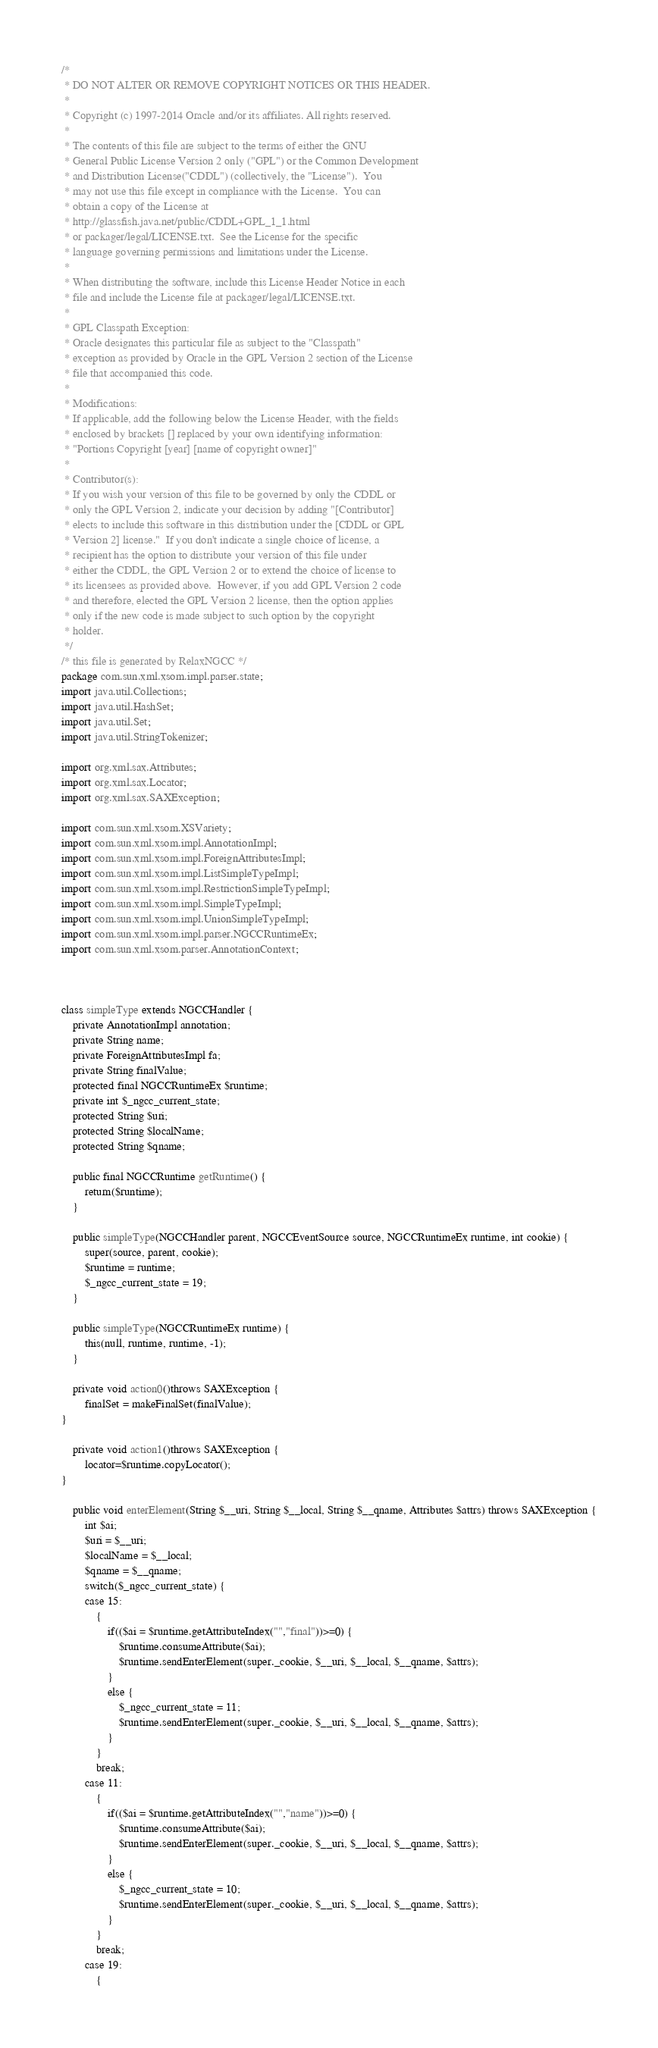Convert code to text. <code><loc_0><loc_0><loc_500><loc_500><_Java_>/*
 * DO NOT ALTER OR REMOVE COPYRIGHT NOTICES OR THIS HEADER.
 *
 * Copyright (c) 1997-2014 Oracle and/or its affiliates. All rights reserved.
 *
 * The contents of this file are subject to the terms of either the GNU
 * General Public License Version 2 only ("GPL") or the Common Development
 * and Distribution License("CDDL") (collectively, the "License").  You
 * may not use this file except in compliance with the License.  You can
 * obtain a copy of the License at
 * http://glassfish.java.net/public/CDDL+GPL_1_1.html
 * or packager/legal/LICENSE.txt.  See the License for the specific
 * language governing permissions and limitations under the License.
 *
 * When distributing the software, include this License Header Notice in each
 * file and include the License file at packager/legal/LICENSE.txt.
 *
 * GPL Classpath Exception:
 * Oracle designates this particular file as subject to the "Classpath"
 * exception as provided by Oracle in the GPL Version 2 section of the License
 * file that accompanied this code.
 *
 * Modifications:
 * If applicable, add the following below the License Header, with the fields
 * enclosed by brackets [] replaced by your own identifying information:
 * "Portions Copyright [year] [name of copyright owner]"
 *
 * Contributor(s):
 * If you wish your version of this file to be governed by only the CDDL or
 * only the GPL Version 2, indicate your decision by adding "[Contributor]
 * elects to include this software in this distribution under the [CDDL or GPL
 * Version 2] license."  If you don't indicate a single choice of license, a
 * recipient has the option to distribute your version of this file under
 * either the CDDL, the GPL Version 2 or to extend the choice of license to
 * its licensees as provided above.  However, if you add GPL Version 2 code
 * and therefore, elected the GPL Version 2 license, then the option applies
 * only if the new code is made subject to such option by the copyright
 * holder.
 */
/* this file is generated by RelaxNGCC */
package com.sun.xml.xsom.impl.parser.state;
import java.util.Collections;
import java.util.HashSet;
import java.util.Set;
import java.util.StringTokenizer;

import org.xml.sax.Attributes;
import org.xml.sax.Locator;
import org.xml.sax.SAXException;

import com.sun.xml.xsom.XSVariety;
import com.sun.xml.xsom.impl.AnnotationImpl;
import com.sun.xml.xsom.impl.ForeignAttributesImpl;
import com.sun.xml.xsom.impl.ListSimpleTypeImpl;
import com.sun.xml.xsom.impl.RestrictionSimpleTypeImpl;
import com.sun.xml.xsom.impl.SimpleTypeImpl;
import com.sun.xml.xsom.impl.UnionSimpleTypeImpl;
import com.sun.xml.xsom.impl.parser.NGCCRuntimeEx;
import com.sun.xml.xsom.parser.AnnotationContext;
  


class simpleType extends NGCCHandler {
    private AnnotationImpl annotation;
    private String name;
    private ForeignAttributesImpl fa;
    private String finalValue;
    protected final NGCCRuntimeEx $runtime;
    private int $_ngcc_current_state;
    protected String $uri;
    protected String $localName;
    protected String $qname;

    public final NGCCRuntime getRuntime() {
        return($runtime);
    }

    public simpleType(NGCCHandler parent, NGCCEventSource source, NGCCRuntimeEx runtime, int cookie) {
        super(source, parent, cookie);
        $runtime = runtime;
        $_ngcc_current_state = 19;
    }

    public simpleType(NGCCRuntimeEx runtime) {
        this(null, runtime, runtime, -1);
    }

    private void action0()throws SAXException {
        finalSet = makeFinalSet(finalValue);
}

    private void action1()throws SAXException {
        locator=$runtime.copyLocator();
}

    public void enterElement(String $__uri, String $__local, String $__qname, Attributes $attrs) throws SAXException {
        int $ai;
        $uri = $__uri;
        $localName = $__local;
        $qname = $__qname;
        switch($_ngcc_current_state) {
        case 15:
            {
                if(($ai = $runtime.getAttributeIndex("","final"))>=0) {
                    $runtime.consumeAttribute($ai);
                    $runtime.sendEnterElement(super._cookie, $__uri, $__local, $__qname, $attrs);
                }
                else {
                    $_ngcc_current_state = 11;
                    $runtime.sendEnterElement(super._cookie, $__uri, $__local, $__qname, $attrs);
                }
            }
            break;
        case 11:
            {
                if(($ai = $runtime.getAttributeIndex("","name"))>=0) {
                    $runtime.consumeAttribute($ai);
                    $runtime.sendEnterElement(super._cookie, $__uri, $__local, $__qname, $attrs);
                }
                else {
                    $_ngcc_current_state = 10;
                    $runtime.sendEnterElement(super._cookie, $__uri, $__local, $__qname, $attrs);
                }
            }
            break;
        case 19:
            {</code> 